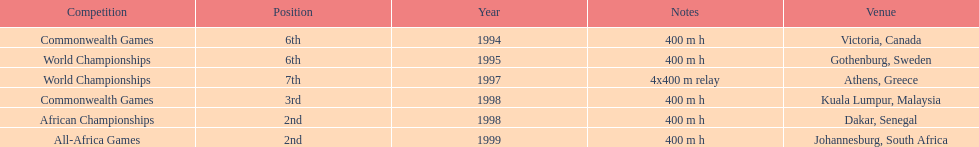Other than 1999, what year did ken harnden win second place? 1998. 